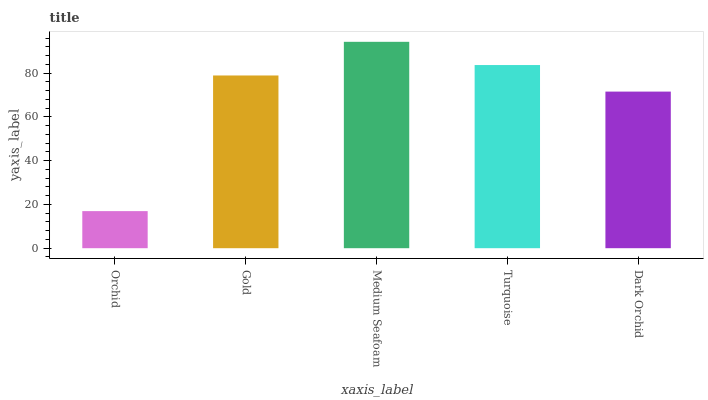Is Orchid the minimum?
Answer yes or no. Yes. Is Medium Seafoam the maximum?
Answer yes or no. Yes. Is Gold the minimum?
Answer yes or no. No. Is Gold the maximum?
Answer yes or no. No. Is Gold greater than Orchid?
Answer yes or no. Yes. Is Orchid less than Gold?
Answer yes or no. Yes. Is Orchid greater than Gold?
Answer yes or no. No. Is Gold less than Orchid?
Answer yes or no. No. Is Gold the high median?
Answer yes or no. Yes. Is Gold the low median?
Answer yes or no. Yes. Is Turquoise the high median?
Answer yes or no. No. Is Medium Seafoam the low median?
Answer yes or no. No. 